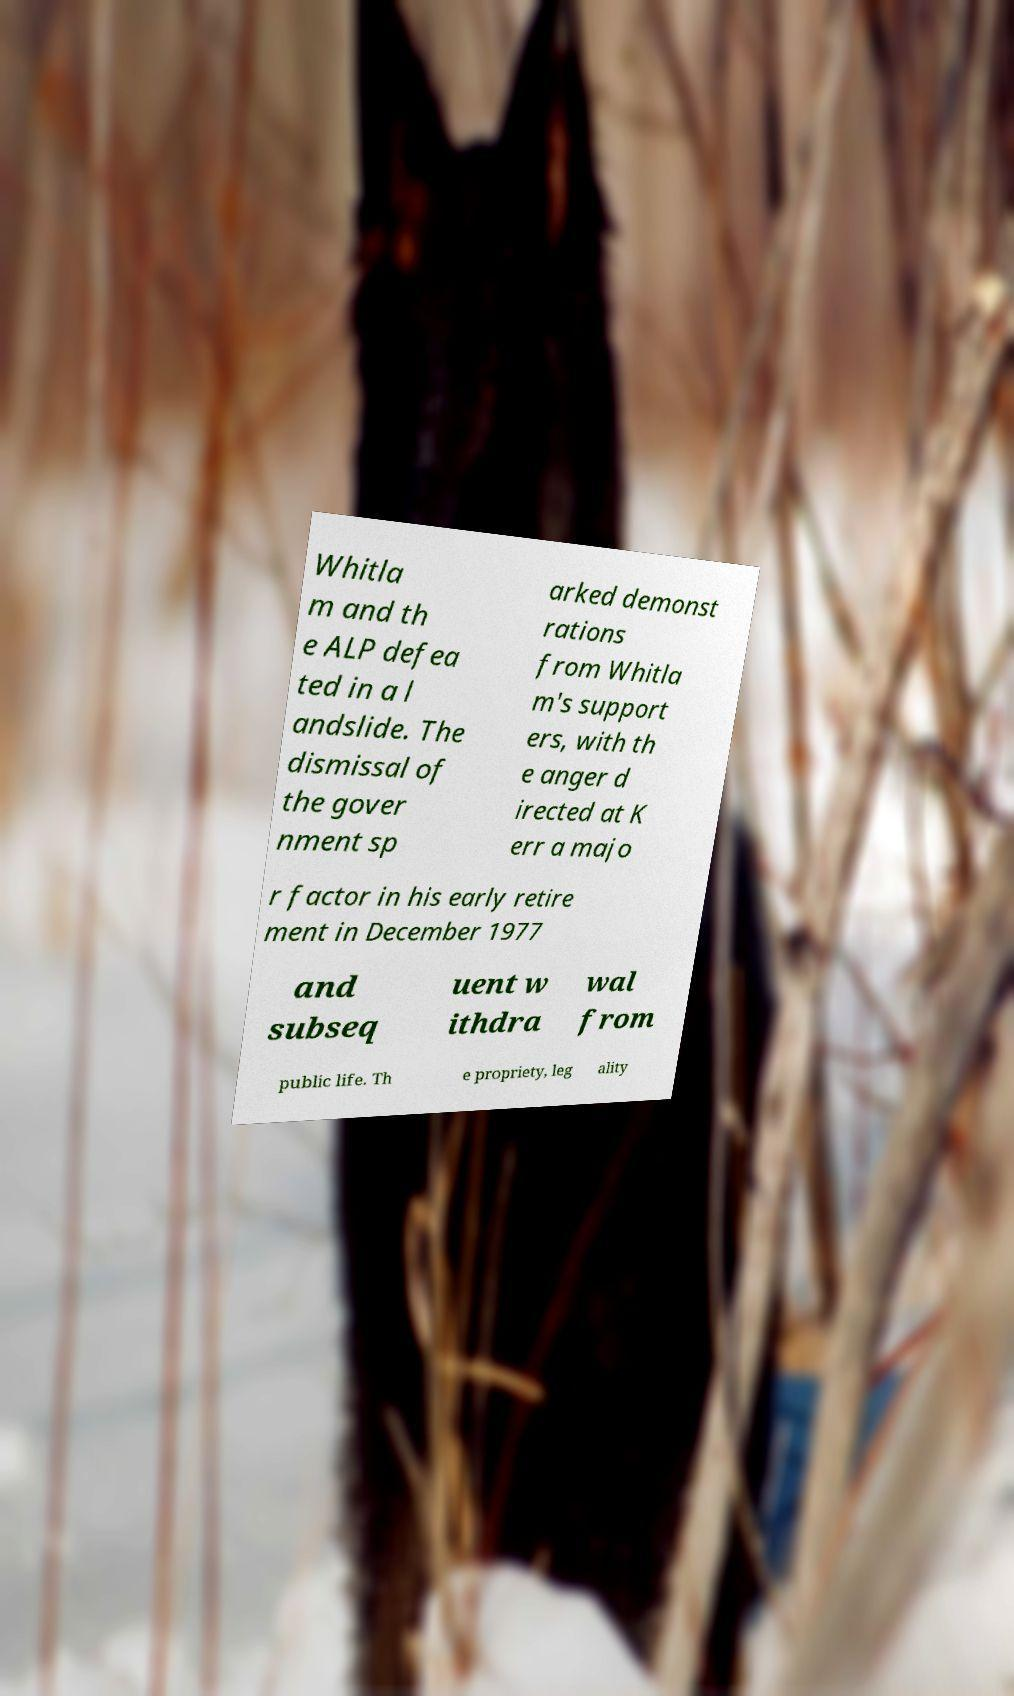Can you read and provide the text displayed in the image?This photo seems to have some interesting text. Can you extract and type it out for me? Whitla m and th e ALP defea ted in a l andslide. The dismissal of the gover nment sp arked demonst rations from Whitla m's support ers, with th e anger d irected at K err a majo r factor in his early retire ment in December 1977 and subseq uent w ithdra wal from public life. Th e propriety, leg ality 